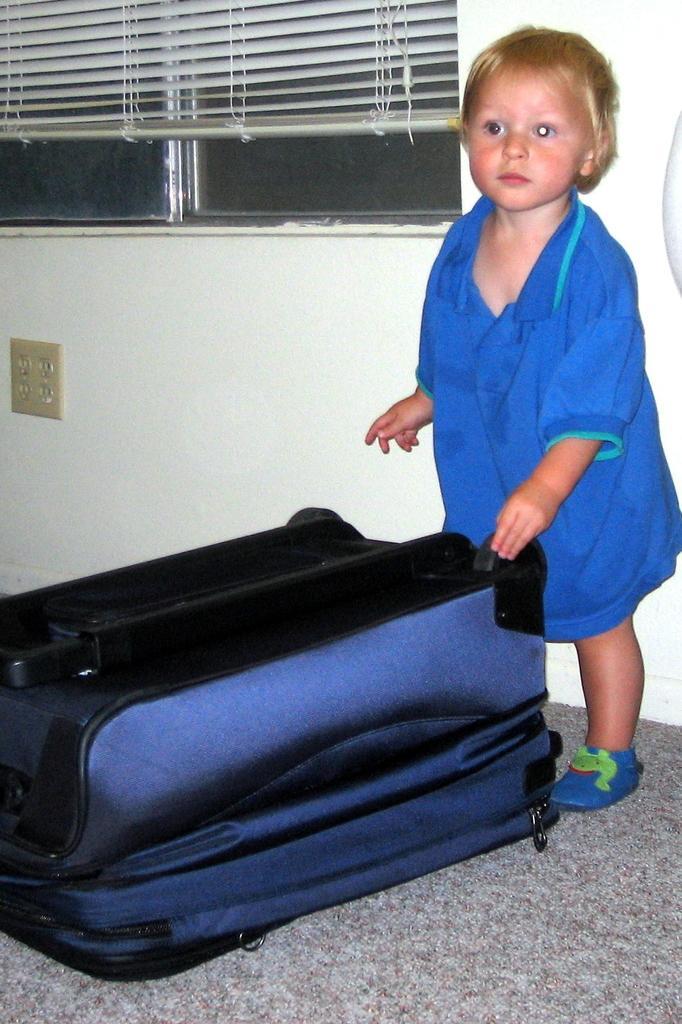Can you describe this image briefly? In this image we can see a child wearing blue color t shirt is standing on the floor and there is a bag in front of him. In the background we can see window blinds. 